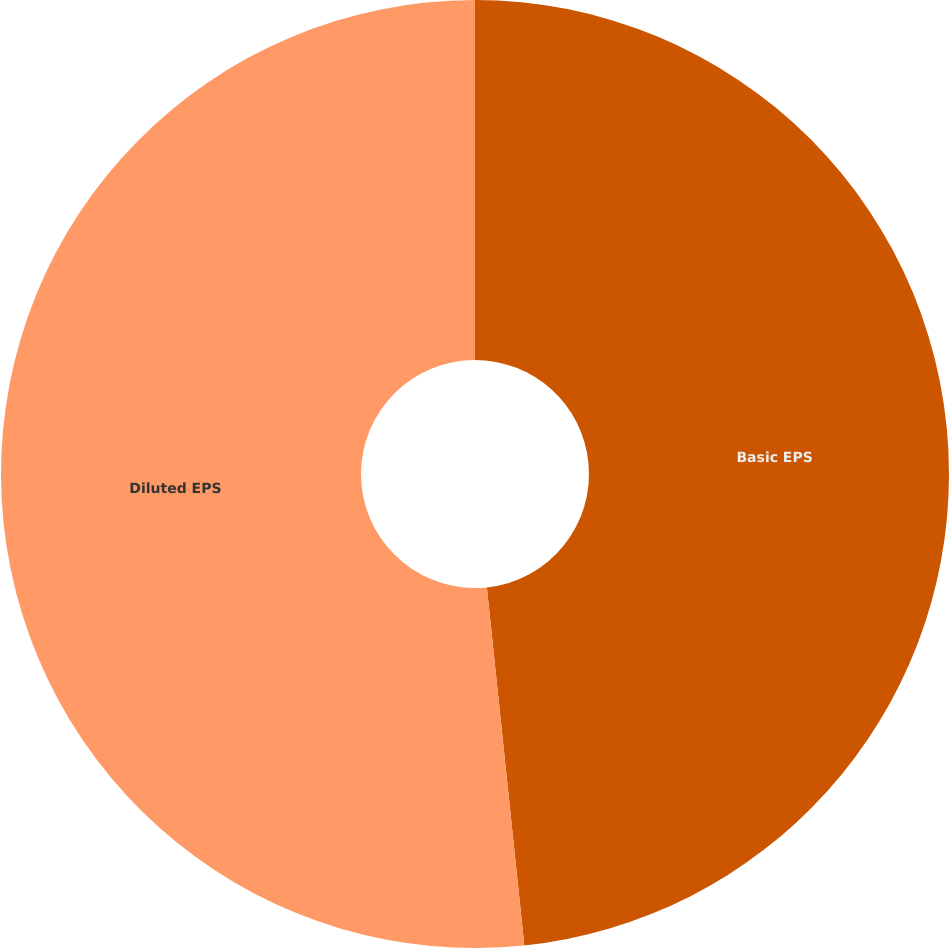Convert chart to OTSL. <chart><loc_0><loc_0><loc_500><loc_500><pie_chart><fcel>Basic EPS<fcel>Diluted EPS<nl><fcel>48.34%<fcel>51.66%<nl></chart> 